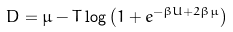<formula> <loc_0><loc_0><loc_500><loc_500>D = \mu - T \log \left ( 1 + e ^ { - \beta U + 2 \beta \mu } \right )</formula> 